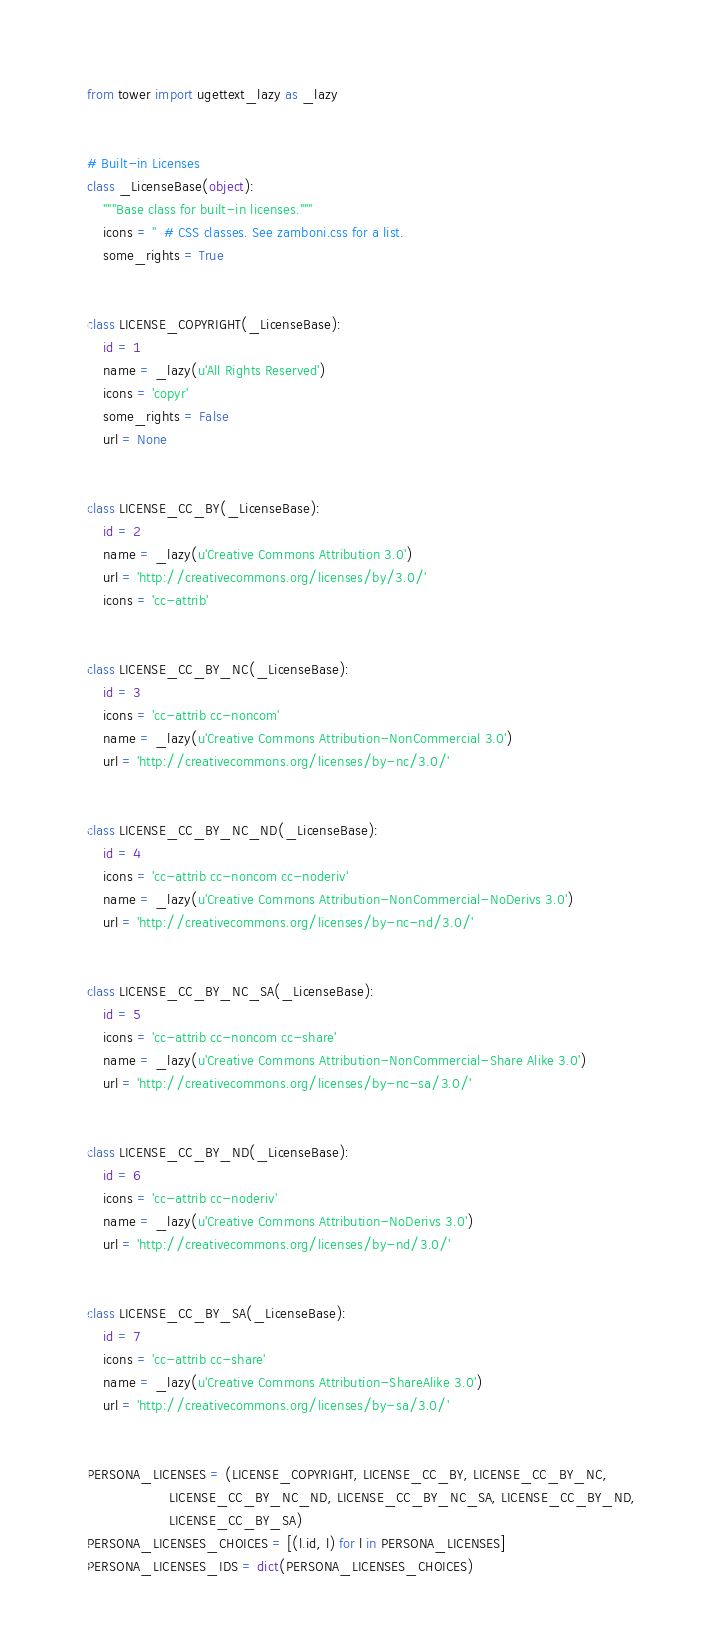Convert code to text. <code><loc_0><loc_0><loc_500><loc_500><_Python_>from tower import ugettext_lazy as _lazy


# Built-in Licenses
class _LicenseBase(object):
    """Base class for built-in licenses."""
    icons = ''  # CSS classes. See zamboni.css for a list.
    some_rights = True


class LICENSE_COPYRIGHT(_LicenseBase):
    id = 1
    name = _lazy(u'All Rights Reserved')
    icons = 'copyr'
    some_rights = False
    url = None


class LICENSE_CC_BY(_LicenseBase):
    id = 2
    name = _lazy(u'Creative Commons Attribution 3.0')
    url = 'http://creativecommons.org/licenses/by/3.0/'
    icons = 'cc-attrib'


class LICENSE_CC_BY_NC(_LicenseBase):
    id = 3
    icons = 'cc-attrib cc-noncom'
    name = _lazy(u'Creative Commons Attribution-NonCommercial 3.0')
    url = 'http://creativecommons.org/licenses/by-nc/3.0/'


class LICENSE_CC_BY_NC_ND(_LicenseBase):
    id = 4
    icons = 'cc-attrib cc-noncom cc-noderiv'
    name = _lazy(u'Creative Commons Attribution-NonCommercial-NoDerivs 3.0')
    url = 'http://creativecommons.org/licenses/by-nc-nd/3.0/'


class LICENSE_CC_BY_NC_SA(_LicenseBase):
    id = 5
    icons = 'cc-attrib cc-noncom cc-share'
    name = _lazy(u'Creative Commons Attribution-NonCommercial-Share Alike 3.0')
    url = 'http://creativecommons.org/licenses/by-nc-sa/3.0/'


class LICENSE_CC_BY_ND(_LicenseBase):
    id = 6
    icons = 'cc-attrib cc-noderiv'
    name = _lazy(u'Creative Commons Attribution-NoDerivs 3.0')
    url = 'http://creativecommons.org/licenses/by-nd/3.0/'


class LICENSE_CC_BY_SA(_LicenseBase):
    id = 7
    icons = 'cc-attrib cc-share'
    name = _lazy(u'Creative Commons Attribution-ShareAlike 3.0')
    url = 'http://creativecommons.org/licenses/by-sa/3.0/'


PERSONA_LICENSES = (LICENSE_COPYRIGHT, LICENSE_CC_BY, LICENSE_CC_BY_NC,
                    LICENSE_CC_BY_NC_ND, LICENSE_CC_BY_NC_SA, LICENSE_CC_BY_ND,
                    LICENSE_CC_BY_SA)
PERSONA_LICENSES_CHOICES = [(l.id, l) for l in PERSONA_LICENSES]
PERSONA_LICENSES_IDS = dict(PERSONA_LICENSES_CHOICES)
</code> 